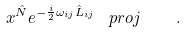Convert formula to latex. <formula><loc_0><loc_0><loc_500><loc_500>x ^ { \hat { N } } e ^ { - \frac { i } { 2 } \omega _ { i j } \hat { L } _ { i j } } \, \ p r o j \, \quad .</formula> 